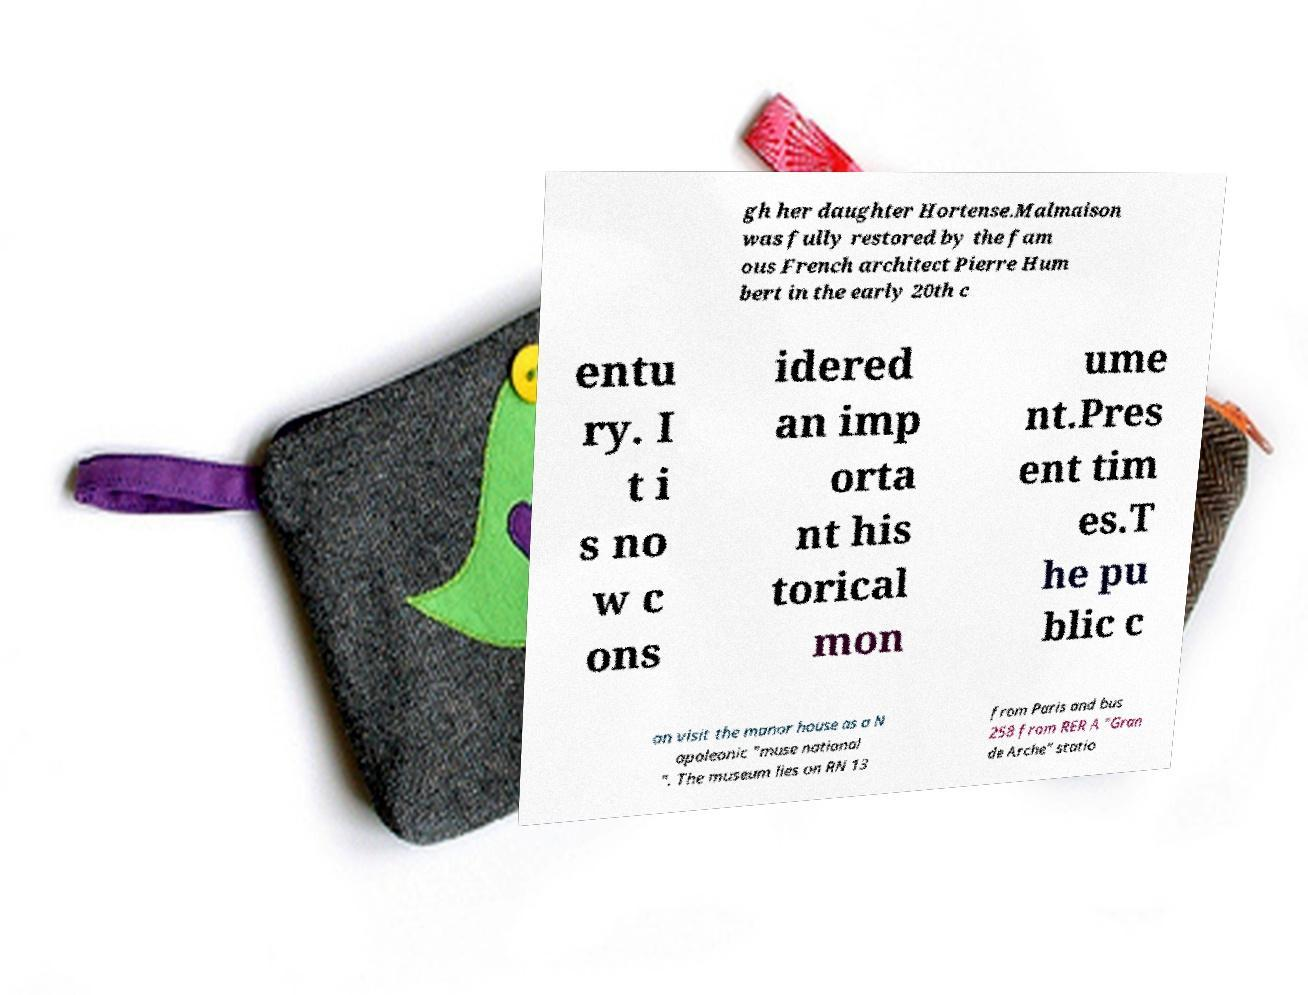I need the written content from this picture converted into text. Can you do that? gh her daughter Hortense.Malmaison was fully restored by the fam ous French architect Pierre Hum bert in the early 20th c entu ry. I t i s no w c ons idered an imp orta nt his torical mon ume nt.Pres ent tim es.T he pu blic c an visit the manor house as a N apoleonic "muse national ". The museum lies on RN 13 from Paris and bus 258 from RER A "Gran de Arche" statio 